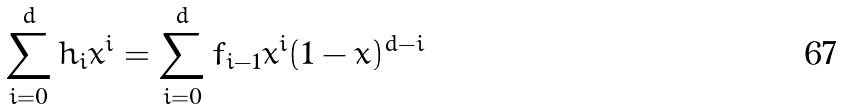<formula> <loc_0><loc_0><loc_500><loc_500>\sum _ { i = 0 } ^ { d } h _ { i } x ^ { i } = \sum _ { i = 0 } ^ { d } f _ { i - 1 } x ^ { i } ( 1 - x ) ^ { d - i }</formula> 